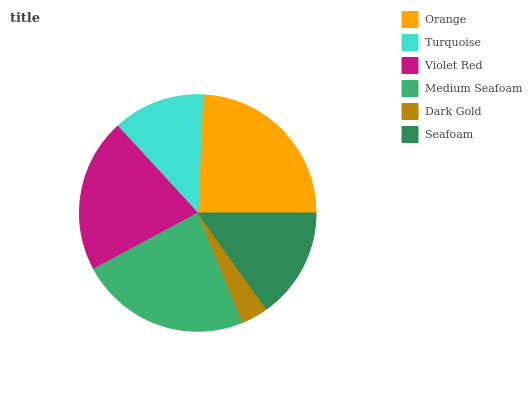Is Dark Gold the minimum?
Answer yes or no. Yes. Is Orange the maximum?
Answer yes or no. Yes. Is Turquoise the minimum?
Answer yes or no. No. Is Turquoise the maximum?
Answer yes or no. No. Is Orange greater than Turquoise?
Answer yes or no. Yes. Is Turquoise less than Orange?
Answer yes or no. Yes. Is Turquoise greater than Orange?
Answer yes or no. No. Is Orange less than Turquoise?
Answer yes or no. No. Is Violet Red the high median?
Answer yes or no. Yes. Is Seafoam the low median?
Answer yes or no. Yes. Is Orange the high median?
Answer yes or no. No. Is Dark Gold the low median?
Answer yes or no. No. 